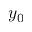Convert formula to latex. <formula><loc_0><loc_0><loc_500><loc_500>y _ { 0 }</formula> 